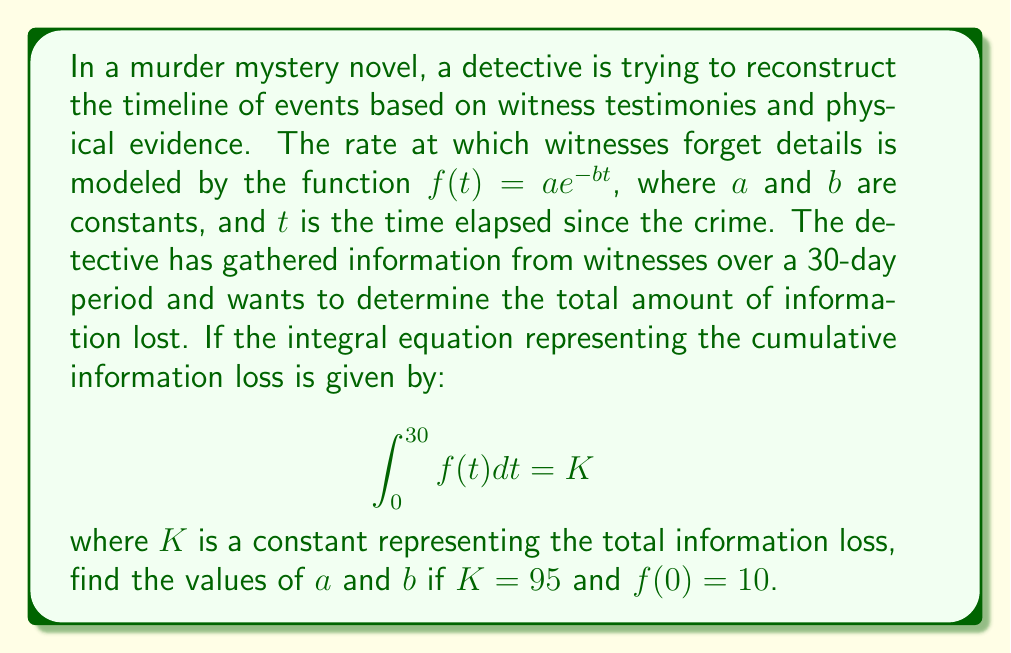Help me with this question. Let's approach this step-by-step:

1) We are given that $f(t) = ae^{-bt}$ and $\int_0^{30} f(t) dt = K = 95$.

2) First, let's solve the integral:

   $$\int_0^{30} ae^{-bt} dt = -\frac{a}{b}e^{-bt}\bigg|_0^{30} = -\frac{a}{b}(e^{-30b} - 1) = 95$$

3) We're also given that $f(0) = 10$. This means:

   $f(0) = ae^{-b(0)} = a = 10$

4) Substituting $a = 10$ into the equation from step 2:

   $$-\frac{10}{b}(e^{-30b} - 1) = 95$$

5) Multiply both sides by $-b$:

   $$10(e^{-30b} - 1) = -95b$$

6) Divide by 10:

   $$e^{-30b} - 1 = -9.5b$$

7) Add 1 to both sides:

   $$e^{-30b} = 1 - 9.5b$$

8) This equation can't be solved algebraically. We need to use numerical methods or a graphing calculator to find $b$. Using such methods, we find:

   $$b \approx 0.0922$$

9) Now that we have $b$, we can confirm $a = 10$.

Therefore, $a = 10$ and $b \approx 0.0922$.
Answer: $a = 10$, $b \approx 0.0922$ 